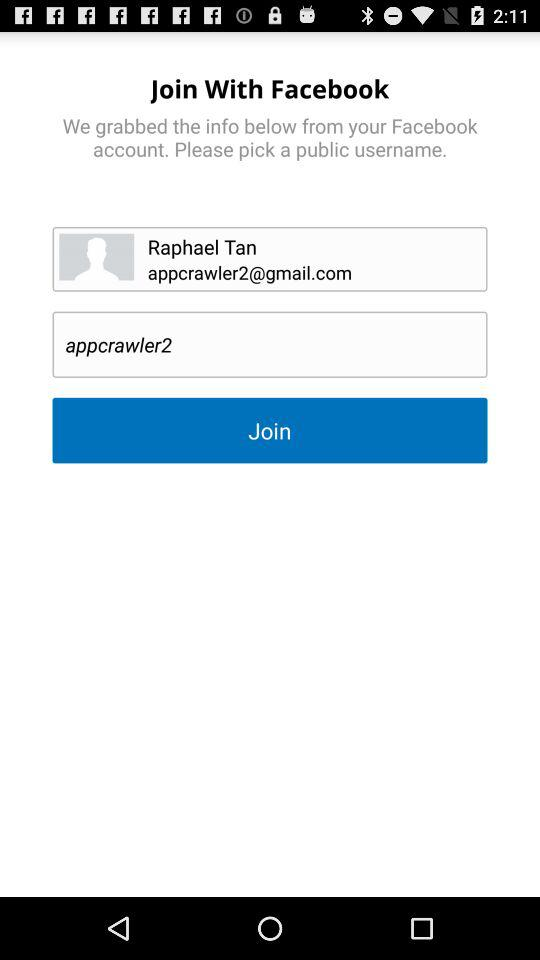What is the email ID of the user? The email ID is appcrawler2@gmail.com. 